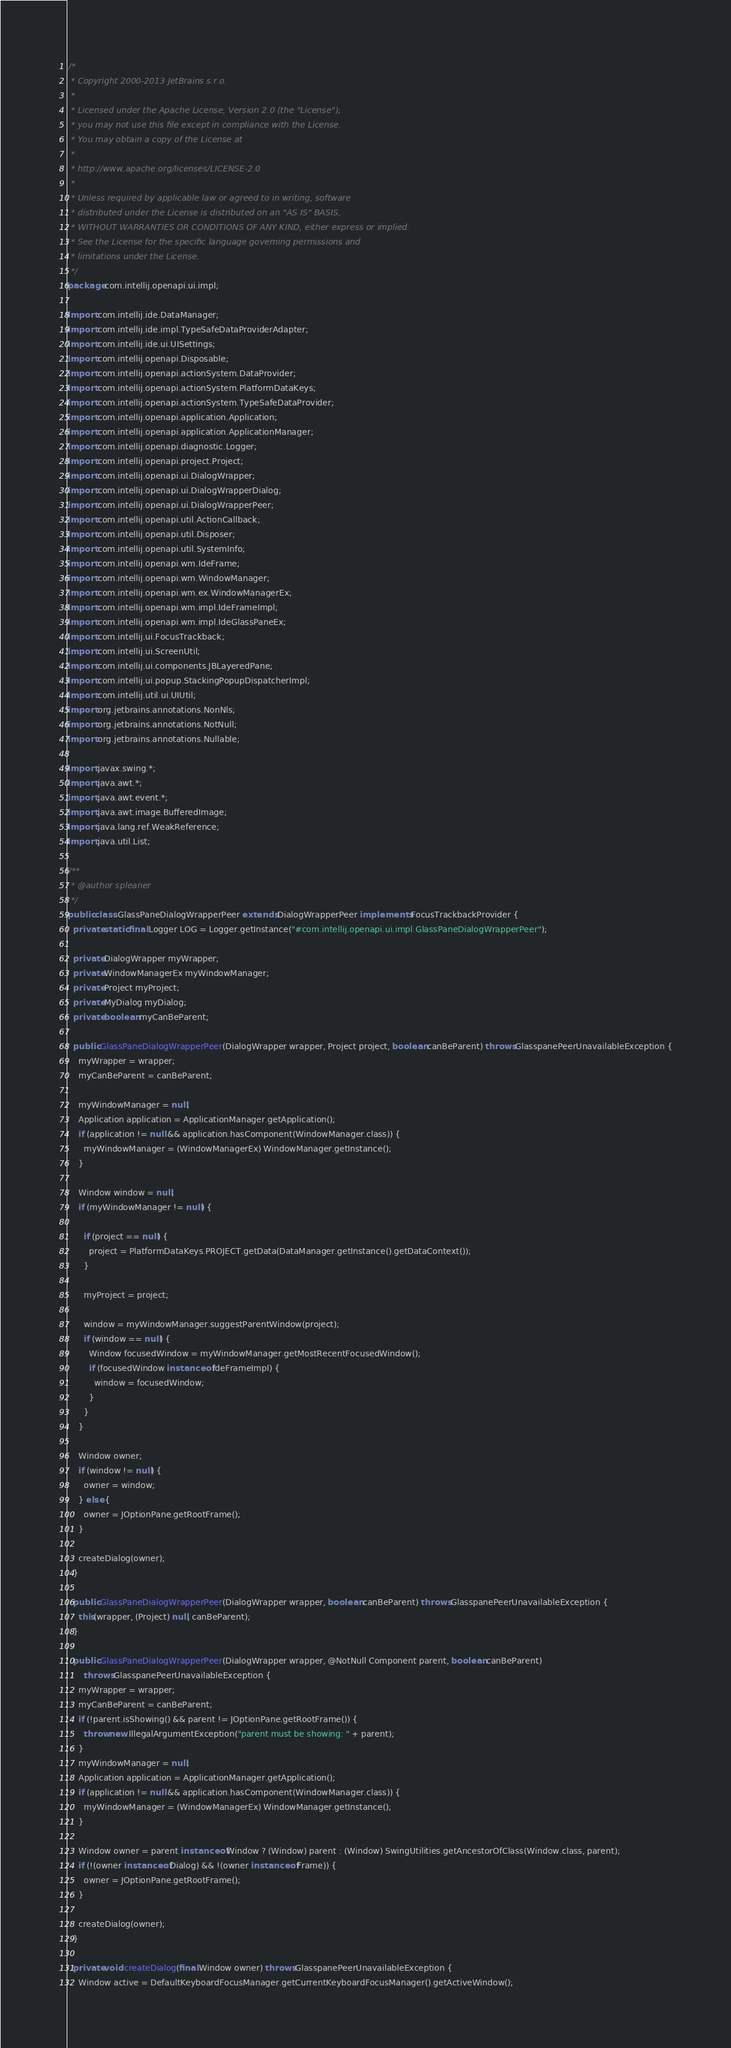<code> <loc_0><loc_0><loc_500><loc_500><_Java_>/*
 * Copyright 2000-2013 JetBrains s.r.o.
 *
 * Licensed under the Apache License, Version 2.0 (the "License");
 * you may not use this file except in compliance with the License.
 * You may obtain a copy of the License at
 *
 * http://www.apache.org/licenses/LICENSE-2.0
 *
 * Unless required by applicable law or agreed to in writing, software
 * distributed under the License is distributed on an "AS IS" BASIS,
 * WITHOUT WARRANTIES OR CONDITIONS OF ANY KIND, either express or implied.
 * See the License for the specific language governing permissions and
 * limitations under the License.
 */
package com.intellij.openapi.ui.impl;

import com.intellij.ide.DataManager;
import com.intellij.ide.impl.TypeSafeDataProviderAdapter;
import com.intellij.ide.ui.UISettings;
import com.intellij.openapi.Disposable;
import com.intellij.openapi.actionSystem.DataProvider;
import com.intellij.openapi.actionSystem.PlatformDataKeys;
import com.intellij.openapi.actionSystem.TypeSafeDataProvider;
import com.intellij.openapi.application.Application;
import com.intellij.openapi.application.ApplicationManager;
import com.intellij.openapi.diagnostic.Logger;
import com.intellij.openapi.project.Project;
import com.intellij.openapi.ui.DialogWrapper;
import com.intellij.openapi.ui.DialogWrapperDialog;
import com.intellij.openapi.ui.DialogWrapperPeer;
import com.intellij.openapi.util.ActionCallback;
import com.intellij.openapi.util.Disposer;
import com.intellij.openapi.util.SystemInfo;
import com.intellij.openapi.wm.IdeFrame;
import com.intellij.openapi.wm.WindowManager;
import com.intellij.openapi.wm.ex.WindowManagerEx;
import com.intellij.openapi.wm.impl.IdeFrameImpl;
import com.intellij.openapi.wm.impl.IdeGlassPaneEx;
import com.intellij.ui.FocusTrackback;
import com.intellij.ui.ScreenUtil;
import com.intellij.ui.components.JBLayeredPane;
import com.intellij.ui.popup.StackingPopupDispatcherImpl;
import com.intellij.util.ui.UIUtil;
import org.jetbrains.annotations.NonNls;
import org.jetbrains.annotations.NotNull;
import org.jetbrains.annotations.Nullable;

import javax.swing.*;
import java.awt.*;
import java.awt.event.*;
import java.awt.image.BufferedImage;
import java.lang.ref.WeakReference;
import java.util.List;

/**
 * @author spleaner
 */
public class GlassPaneDialogWrapperPeer extends DialogWrapperPeer implements FocusTrackbackProvider {
  private static final Logger LOG = Logger.getInstance("#com.intellij.openapi.ui.impl.GlassPaneDialogWrapperPeer");

  private DialogWrapper myWrapper;
  private WindowManagerEx myWindowManager;
  private Project myProject;
  private MyDialog myDialog;
  private boolean myCanBeParent;

  public GlassPaneDialogWrapperPeer(DialogWrapper wrapper, Project project, boolean canBeParent) throws GlasspanePeerUnavailableException {
    myWrapper = wrapper;
    myCanBeParent = canBeParent;

    myWindowManager = null;
    Application application = ApplicationManager.getApplication();
    if (application != null && application.hasComponent(WindowManager.class)) {
      myWindowManager = (WindowManagerEx) WindowManager.getInstance();
    }

    Window window = null;
    if (myWindowManager != null) {

      if (project == null) {
        project = PlatformDataKeys.PROJECT.getData(DataManager.getInstance().getDataContext());
      }

      myProject = project;

      window = myWindowManager.suggestParentWindow(project);
      if (window == null) {
        Window focusedWindow = myWindowManager.getMostRecentFocusedWindow();
        if (focusedWindow instanceof IdeFrameImpl) {
          window = focusedWindow;
        }
      }
    }

    Window owner;
    if (window != null) {
      owner = window;
    } else {
      owner = JOptionPane.getRootFrame();
    }

    createDialog(owner);
  }

  public GlassPaneDialogWrapperPeer(DialogWrapper wrapper, boolean canBeParent) throws GlasspanePeerUnavailableException {
    this(wrapper, (Project) null, canBeParent);
  }

  public GlassPaneDialogWrapperPeer(DialogWrapper wrapper, @NotNull Component parent, boolean canBeParent)
      throws GlasspanePeerUnavailableException {
    myWrapper = wrapper;
    myCanBeParent = canBeParent;
    if (!parent.isShowing() && parent != JOptionPane.getRootFrame()) {
      throw new IllegalArgumentException("parent must be showing: " + parent);
    }
    myWindowManager = null;
    Application application = ApplicationManager.getApplication();
    if (application != null && application.hasComponent(WindowManager.class)) {
      myWindowManager = (WindowManagerEx) WindowManager.getInstance();
    }

    Window owner = parent instanceof Window ? (Window) parent : (Window) SwingUtilities.getAncestorOfClass(Window.class, parent);
    if (!(owner instanceof Dialog) && !(owner instanceof Frame)) {
      owner = JOptionPane.getRootFrame();
    }

    createDialog(owner);
  }

  private void createDialog(final Window owner) throws GlasspanePeerUnavailableException {
    Window active = DefaultKeyboardFocusManager.getCurrentKeyboardFocusManager().getActiveWindow();</code> 